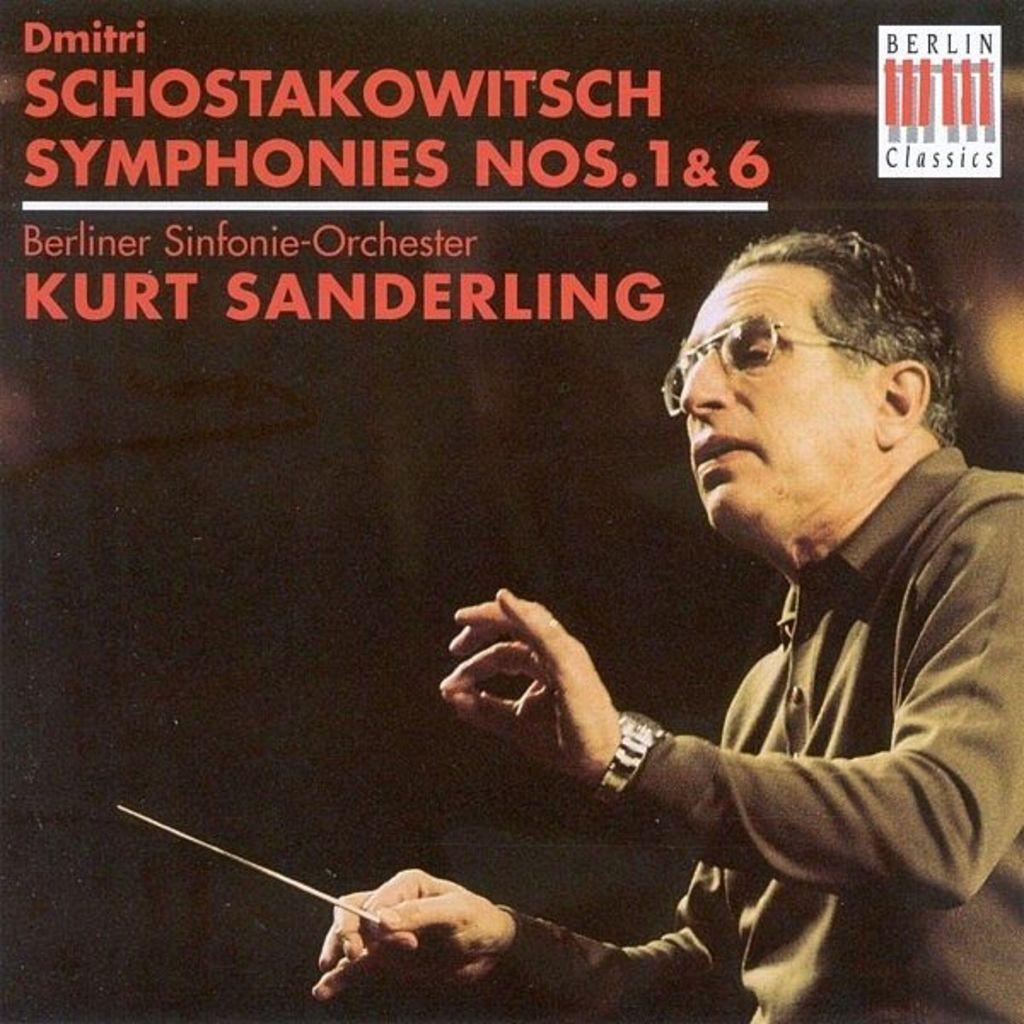Describe this image in one or two sentences. Poster of a person. This person is holding a stick and wore spectacles. Something written on this poster. 